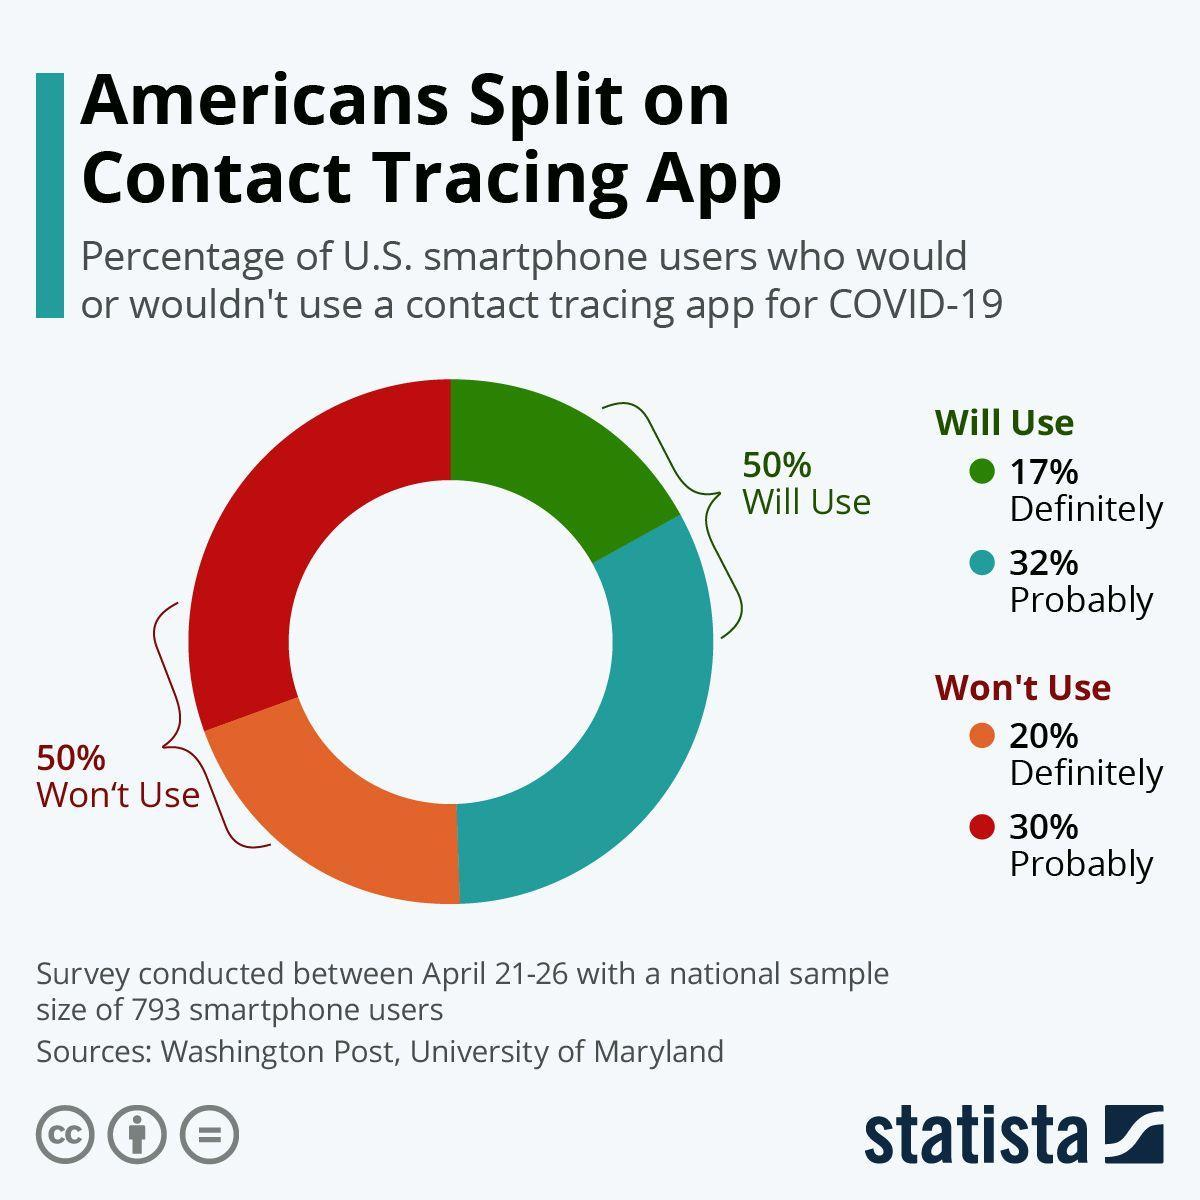What percentage of U.S. smartphone users definitely won't use a contact tracing app for COVID-19 as per the survey?
Answer the question with a short phrase. 20% What percentage of U.S. smartphone users probably won't use a contact tracing app for COVID-19 as per the survey? 30% What percentage of U.S. smartphone users definitely would use a contact tracing app for COVID-19 as per the survey? 17% What percentage of U.S. smartphone users would probably use a contact tracing app for COVID-19 as per the survey? 32% 